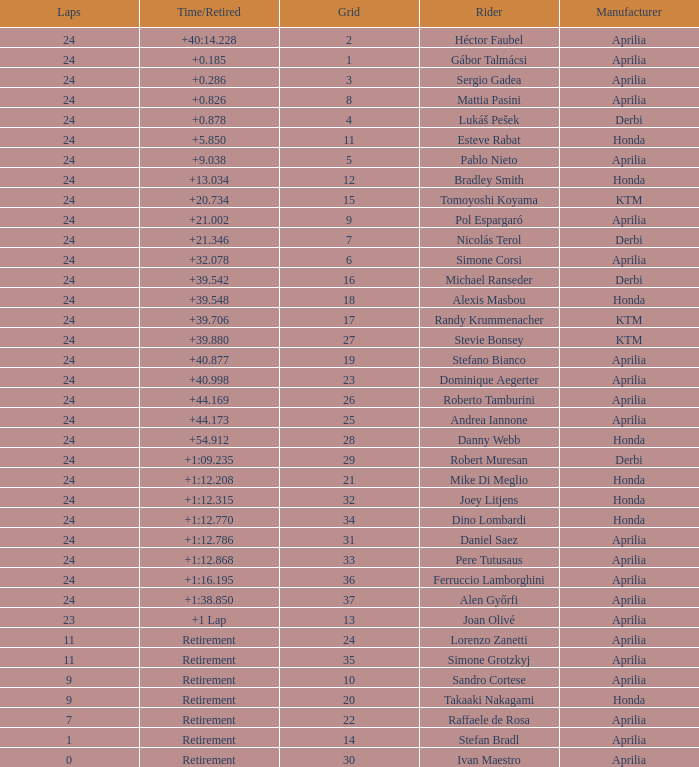Can you parse all the data within this table? {'header': ['Laps', 'Time/Retired', 'Grid', 'Rider', 'Manufacturer'], 'rows': [['24', '+40:14.228', '2', 'Héctor Faubel', 'Aprilia'], ['24', '+0.185', '1', 'Gábor Talmácsi', 'Aprilia'], ['24', '+0.286', '3', 'Sergio Gadea', 'Aprilia'], ['24', '+0.826', '8', 'Mattia Pasini', 'Aprilia'], ['24', '+0.878', '4', 'Lukáš Pešek', 'Derbi'], ['24', '+5.850', '11', 'Esteve Rabat', 'Honda'], ['24', '+9.038', '5', 'Pablo Nieto', 'Aprilia'], ['24', '+13.034', '12', 'Bradley Smith', 'Honda'], ['24', '+20.734', '15', 'Tomoyoshi Koyama', 'KTM'], ['24', '+21.002', '9', 'Pol Espargaró', 'Aprilia'], ['24', '+21.346', '7', 'Nicolás Terol', 'Derbi'], ['24', '+32.078', '6', 'Simone Corsi', 'Aprilia'], ['24', '+39.542', '16', 'Michael Ranseder', 'Derbi'], ['24', '+39.548', '18', 'Alexis Masbou', 'Honda'], ['24', '+39.706', '17', 'Randy Krummenacher', 'KTM'], ['24', '+39.880', '27', 'Stevie Bonsey', 'KTM'], ['24', '+40.877', '19', 'Stefano Bianco', 'Aprilia'], ['24', '+40.998', '23', 'Dominique Aegerter', 'Aprilia'], ['24', '+44.169', '26', 'Roberto Tamburini', 'Aprilia'], ['24', '+44.173', '25', 'Andrea Iannone', 'Aprilia'], ['24', '+54.912', '28', 'Danny Webb', 'Honda'], ['24', '+1:09.235', '29', 'Robert Muresan', 'Derbi'], ['24', '+1:12.208', '21', 'Mike Di Meglio', 'Honda'], ['24', '+1:12.315', '32', 'Joey Litjens', 'Honda'], ['24', '+1:12.770', '34', 'Dino Lombardi', 'Honda'], ['24', '+1:12.786', '31', 'Daniel Saez', 'Aprilia'], ['24', '+1:12.868', '33', 'Pere Tutusaus', 'Aprilia'], ['24', '+1:16.195', '36', 'Ferruccio Lamborghini', 'Aprilia'], ['24', '+1:38.850', '37', 'Alen Győrfi', 'Aprilia'], ['23', '+1 Lap', '13', 'Joan Olivé', 'Aprilia'], ['11', 'Retirement', '24', 'Lorenzo Zanetti', 'Aprilia'], ['11', 'Retirement', '35', 'Simone Grotzkyj', 'Aprilia'], ['9', 'Retirement', '10', 'Sandro Cortese', 'Aprilia'], ['9', 'Retirement', '20', 'Takaaki Nakagami', 'Honda'], ['7', 'Retirement', '22', 'Raffaele de Rosa', 'Aprilia'], ['1', 'Retirement', '14', 'Stefan Bradl', 'Aprilia'], ['0', 'Retirement', '30', 'Ivan Maestro', 'Aprilia']]} How many grids correspond to more than 24 laps? None. 